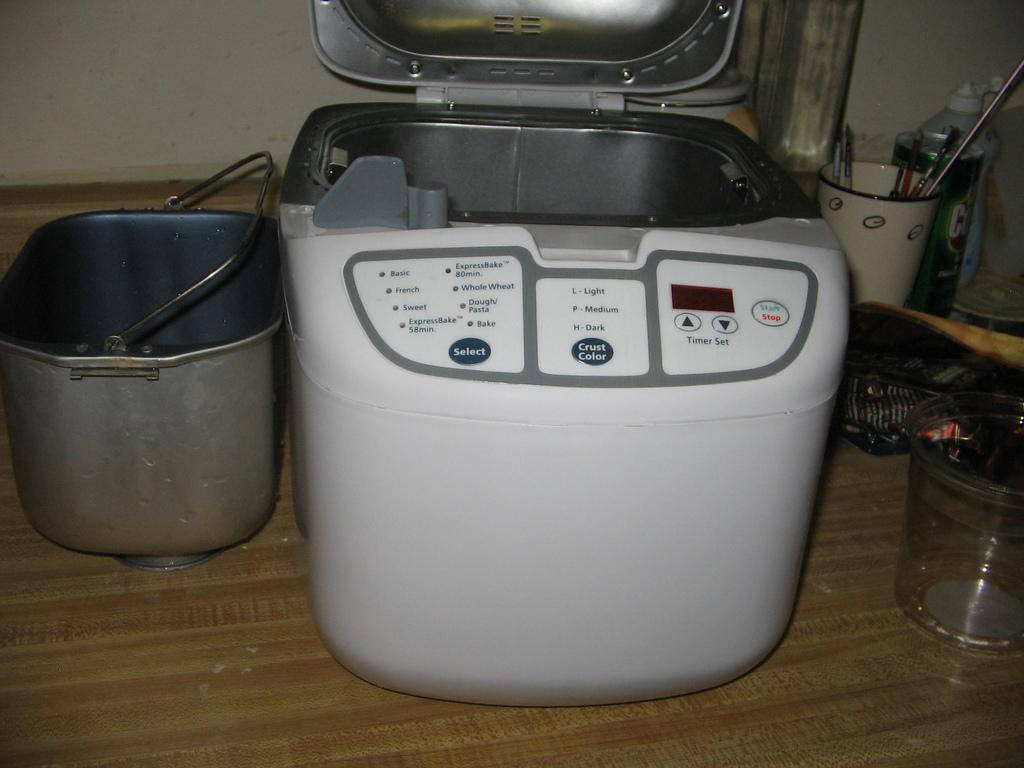What is one of the objects visible in the image? There is a bucket in the image. What type of equipment can be seen in the image? There is a machine in the image. What type of container is present in the image? There is a glass in the image. What other type of container is present in the image? There is a cup in the image. What can be observed on a flat surface in the image? There are other unspecified objects on a flat surface in the image. How does the kite contribute to the weight of the objects in the image? There is no kite present in the image, so its weight cannot be considered. 